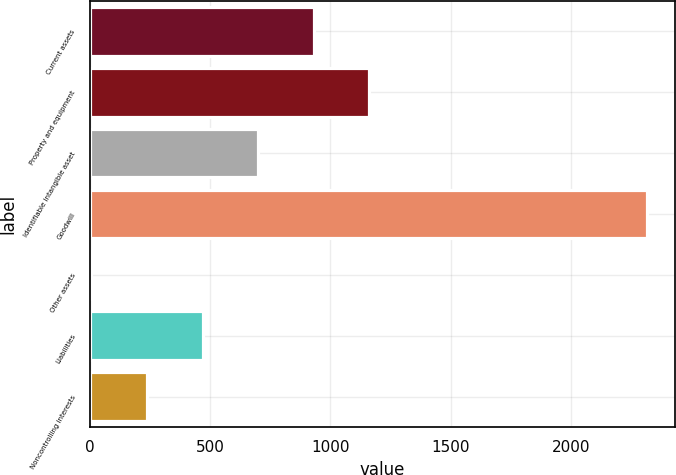<chart> <loc_0><loc_0><loc_500><loc_500><bar_chart><fcel>Current assets<fcel>Property and equipment<fcel>Identifiable intangible asset<fcel>Goodwill<fcel>Other assets<fcel>Liabilities<fcel>Noncontrolling interests<nl><fcel>931<fcel>1162<fcel>700<fcel>2317<fcel>7<fcel>469<fcel>238<nl></chart> 